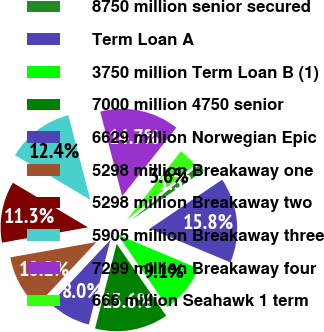<chart> <loc_0><loc_0><loc_500><loc_500><pie_chart><fcel>8750 million senior secured<fcel>Term Loan A<fcel>3750 million Term Loan B (1)<fcel>7000 million 4750 senior<fcel>6629 million Norwegian Epic<fcel>5298 million Breakaway one<fcel>5298 million Breakaway two<fcel>5905 million Breakaway three<fcel>7299 million Breakaway four<fcel>666 million Seahawk 1 term<nl><fcel>1.33%<fcel>15.78%<fcel>9.11%<fcel>13.56%<fcel>8.0%<fcel>10.22%<fcel>11.33%<fcel>12.44%<fcel>14.67%<fcel>3.56%<nl></chart> 